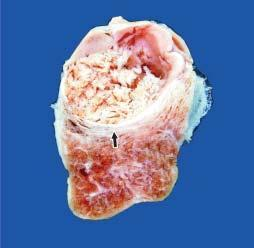does the border of the elevated lesion at the lateral margin show a single nodule separated from the rest of thyroid parenchyma by incomplete fibrous septa?
Answer the question using a single word or phrase. No 